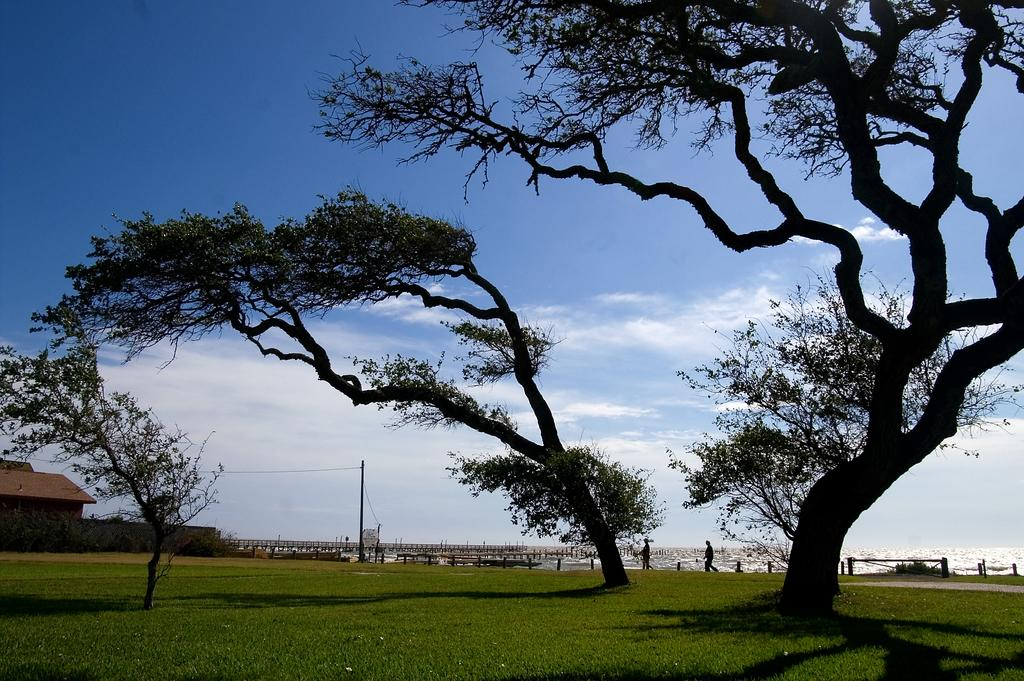What type of vegetation is present on the ground in the image? There is grass on the ground in the image. What other natural elements can be seen in the image? There are trees in the image. What is visible in the sky in the background of the image? There are clouds visible in the sky in the background of the image. What grade does the art piece in the image receive? There is no art piece present in the image, so it is not possible to assign a grade. How does the stomach of the person in the image feel? There is no person present in the image, so it is not possible to determine how their stomach feels. 